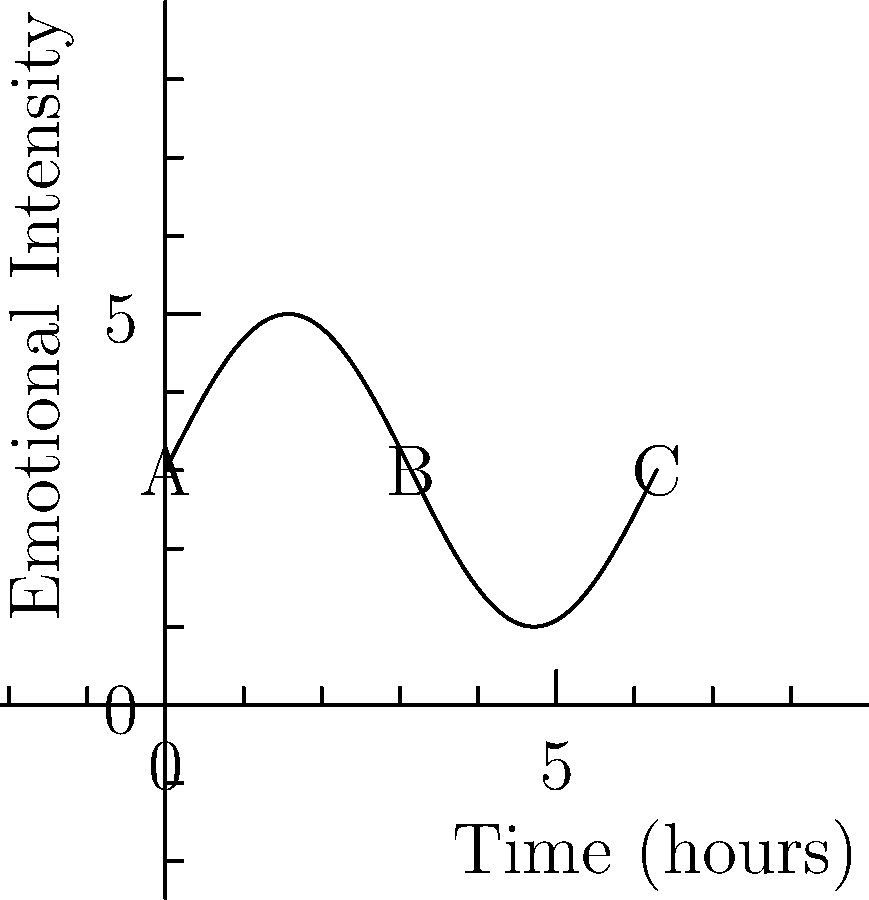The graph represents the emotional intensity experienced by readers during a 6-hour reading session of a science fiction novel. If the function describing this curve is $f(x) = 2\sin(x) + 3$, where $x$ is in hours, calculate the total emotional impact (area under the curve) for the entire reading session. Round your answer to two decimal places. To find the area under the curve, we need to integrate the function $f(x) = 2\sin(x) + 3$ from 0 to $2\pi$ (representing 6 hours).

1) Set up the definite integral:
   $$\int_0^{2\pi} (2\sin(x) + 3) dx$$

2) Integrate each term separately:
   $$\int_0^{2\pi} 2\sin(x) dx + \int_0^{2\pi} 3 dx$$

3) For the sine term:
   $$[-2\cos(x)]_0^{2\pi} = [-2\cos(2\pi) + 2\cos(0)] = [-2(1) + 2(1)] = 0$$

4) For the constant term:
   $$[3x]_0^{2\pi} = 3(2\pi) - 3(0) = 6\pi$$

5) Sum the results:
   $$0 + 6\pi = 6\pi$$

6) Convert to a decimal and round to two places:
   $$6\pi \approx 18.85$$

Therefore, the total emotional impact over the 6-hour reading session is approximately 18.85 units.
Answer: 18.85 